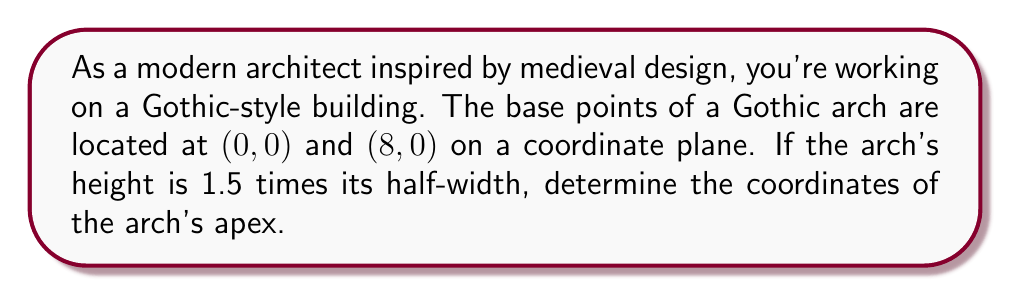What is the answer to this math problem? To solve this problem, let's follow these steps:

1) First, we need to understand the structure of a Gothic arch. It's typically formed by two circular segments that meet at an apex.

2) The width of the arch is the distance between the base points:
   $8 - 0 = 8$ units

3) The half-width is therefore:
   $8 \div 2 = 4$ units

4) We're told that the height is 1.5 times the half-width:
   $\text{Height} = 1.5 \times 4 = 6$ units

5) Now, we can determine the coordinates of the apex:
   - The x-coordinate will be halfway between the base points:
     $x = (0 + 8) \div 2 = 4$
   - The y-coordinate will be the height we calculated:
     $y = 6$

6) Therefore, the coordinates of the apex are $(4, 6)$

[asy]
unitsize(0.5cm);
draw((0,0)--(8,0), arrow=Arrow(TeXHead));
draw((0,0)--(0,8), arrow=Arrow(TeXHead));
draw((0,0)..(4,6)..(8,0), blue);
dot((0,0));
dot((8,0));
dot((4,6));
label("(0,0)", (0,0), SW);
label("(8,0)", (8,0), SE);
label("(4,6)", (4,6), N);
label("x", (8,0), S);
label("y", (0,8), W);
[/asy]

This approach allows us to precisely locate the apex of the Gothic arch, which is crucial for maintaining the authentic proportions and aesthetics of medieval architecture in a modern design context.
Answer: The coordinates of the Gothic arch's apex are $(4, 6)$. 